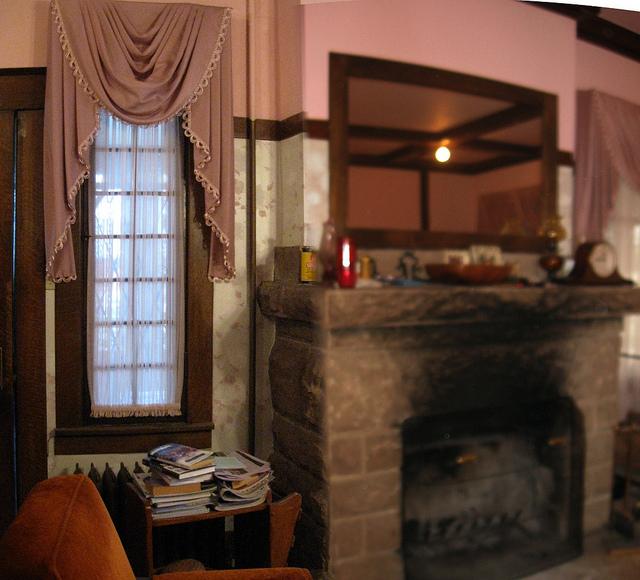Can you see through the window?
Give a very brief answer. No. Is the room dark?
Answer briefly. No. What is the vase sitting on?
Short answer required. Mantle. What time of day is it?
Short answer required. Afternoon. What color is the chair?
Give a very brief answer. Orange. What is glowing red in the fireplace?
Give a very brief answer. Fire. What is standing on the table by the window?
Answer briefly. Books. Do you like the wallpaper?
Keep it brief. No. What color are the curtains?
Short answer required. Taupe. Does the fireplace appear to be used?
Quick response, please. Yes. What are the objects on the table?
Concise answer only. Books. What color are the drapes?
Short answer required. Brown. Is a light being reflected?
Keep it brief. Yes. How many books are in the picture?
Write a very short answer. 10. How many books are there?
Keep it brief. 5. Is there stained glass present in the photo?
Give a very brief answer. No. What is in the vase?
Answer briefly. Nothing. 